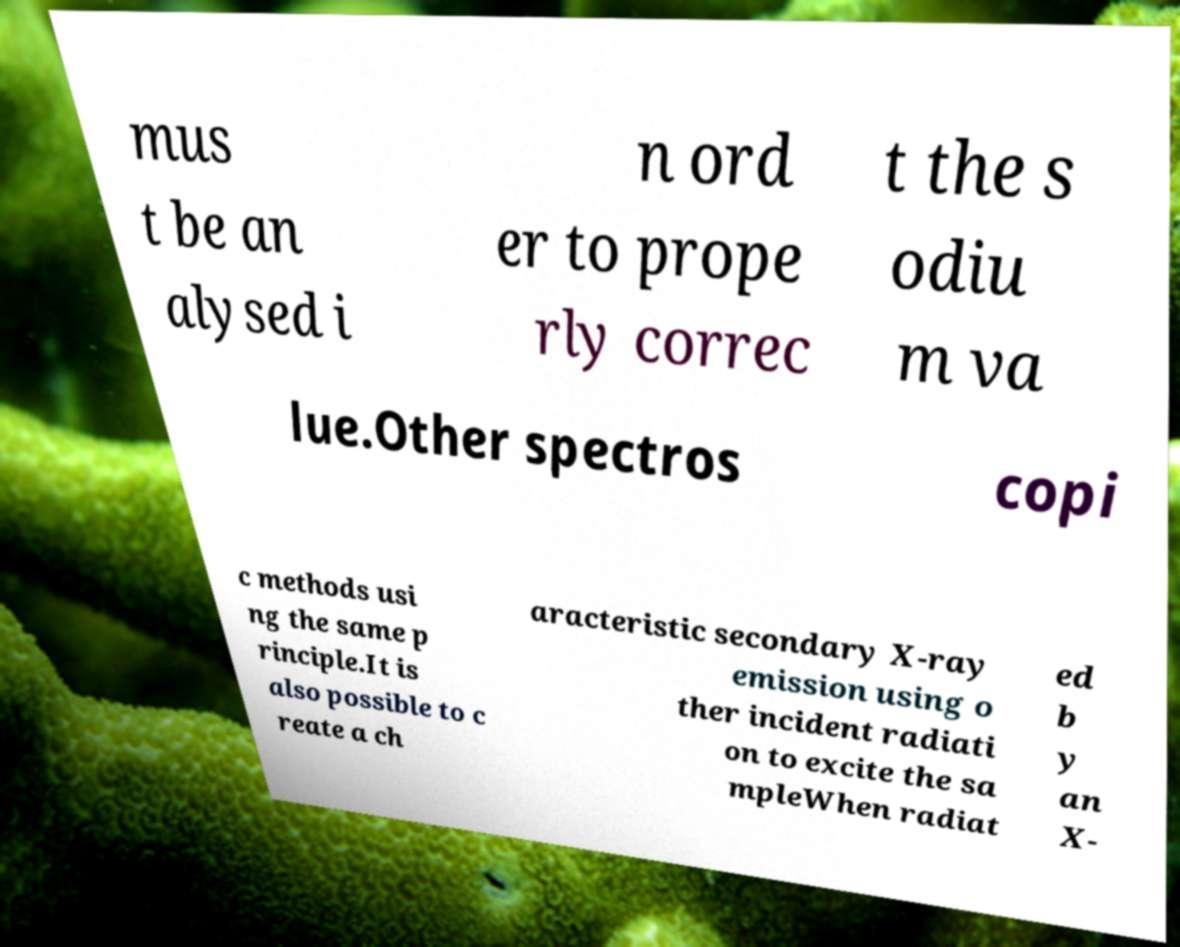What messages or text are displayed in this image? I need them in a readable, typed format. mus t be an alysed i n ord er to prope rly correc t the s odiu m va lue.Other spectros copi c methods usi ng the same p rinciple.It is also possible to c reate a ch aracteristic secondary X-ray emission using o ther incident radiati on to excite the sa mpleWhen radiat ed b y an X- 